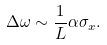<formula> <loc_0><loc_0><loc_500><loc_500>\Delta \omega \sim \frac { 1 } { L } \alpha \sigma _ { x } .</formula> 